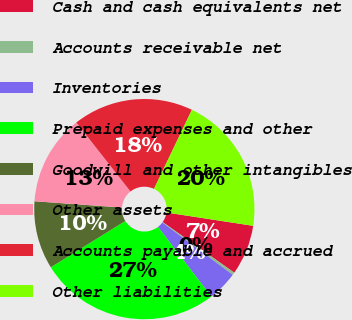Convert chart. <chart><loc_0><loc_0><loc_500><loc_500><pie_chart><fcel>Cash and cash equivalents net<fcel>Accounts receivable net<fcel>Inventories<fcel>Prepaid expenses and other<fcel>Goodwill and other intangibles<fcel>Other assets<fcel>Accounts payable and accrued<fcel>Other liabilities<nl><fcel>7.37%<fcel>0.38%<fcel>4.42%<fcel>26.55%<fcel>9.99%<fcel>13.27%<fcel>17.7%<fcel>20.31%<nl></chart> 